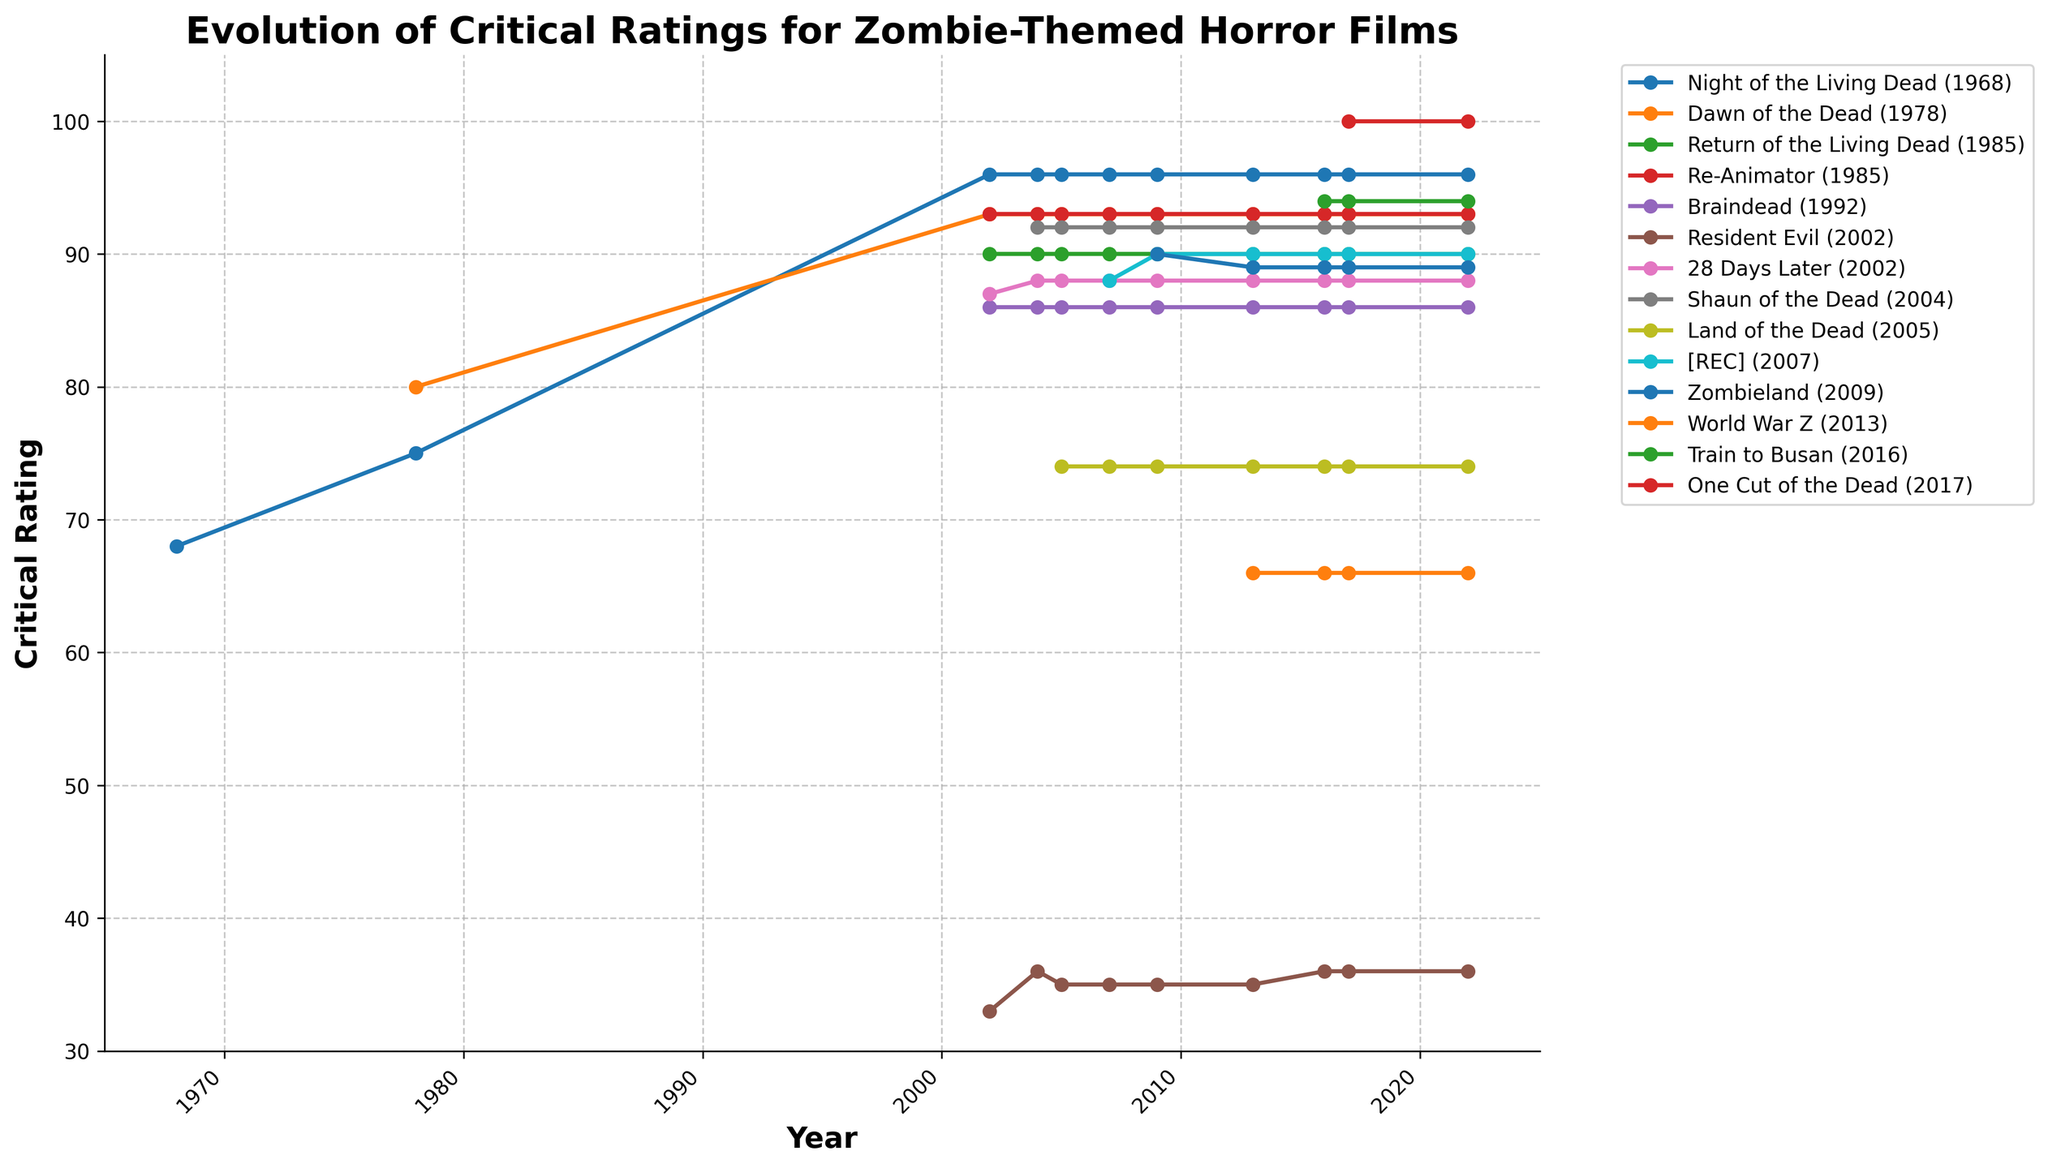Which film has the highest critical rating in 2022? One Cut of the Dead has the highest critical rating in 2022. By looking at the chart, One Cut of the Dead's line reaches the top of the y-axis, indicating a rating of 100.
Answer: One Cut of the Dead How did the critical rating for Resident Evil change from its release in 2002 to 2005? The critical rating for Resident Evil in 2002 was 33. By 2005, the rating slightly increased to 35.
Answer: It increased Which year shows the most significant increase in critical ratings for Land of the Dead? Land of the Dead was introduced in 2005 with a rating of 74. The line representing Land of the Dead appears for the first time in 2005, showing a significant increase compared to previous years where it did not exist.
Answer: 2005 What is the average critical rating of Shaun of the Dead from 2004 to 2022? Shaun of the Dead has consistent ratings for each year: 2004 (92), 2005 (92), 2007 (92), 2009 (92), 2013 (92), 2016 (92), 2017 (92), and 2022 (92). Summing these up gives 736, and there are 8 ratings. Thus, the average rating is 736/8.
Answer: 92 Which films have a higher critical rating in 2016 compared to World War Z? In 2016, World War Z's rating is 66. By examining the visual data, Train to Busan (94), Zombieland (89), Shaun of the Dead (92), 28 Days Later (88), and Night of the Living Dead (96) all have higher ratings.
Answer: Train to Busan, Zombieland, Shaun of the Dead, 28 Days Later, Night of the Living Dead Which film had a critical rating decrease after 2009? Resident Evil had a critical rating decrease after 2009, dropping from 35 in 2009 to 33 in 2013.
Answer: Resident Evil Compare the critical ratings of 28 Days Later and [REC] in 2007. Which one has a higher rating and by how much? In 2007, 28 Days Later had a rating of 88, while [REC] had a rating of 88. Both films have the same rating, so the difference is 0.
Answer: They are equal Calculate the difference in critical ratings between Train to Busan and One Cut of the Dead in 2017. In 2017, Train to Busan has a rating of 94, and One Cut of the Dead has a rating of 100. The difference between them is 100 - 94.
Answer: 6 